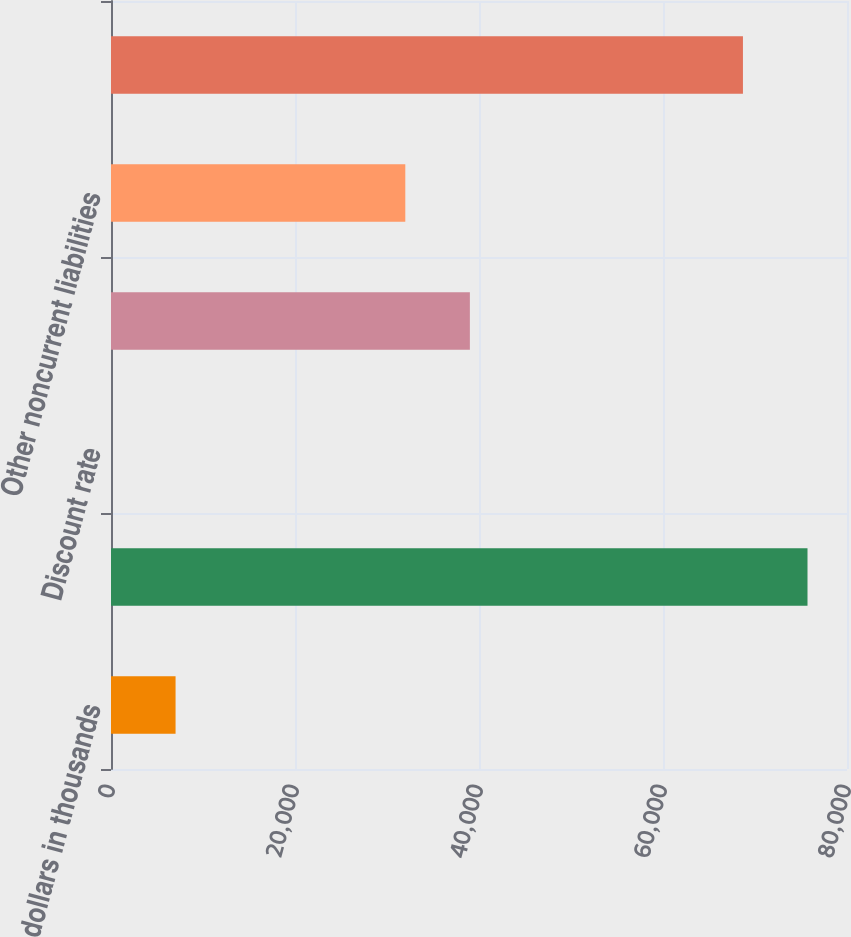Convert chart. <chart><loc_0><loc_0><loc_500><loc_500><bar_chart><fcel>dollars in thousands<fcel>Liabilities (undiscounted)<fcel>Discount rate<fcel>Other accrued liabilities<fcel>Other noncurrent liabilities<fcel>Accrued liabilities<nl><fcel>7018.31<fcel>75706.3<fcel>1.01<fcel>39007.3<fcel>31990<fcel>68689<nl></chart> 